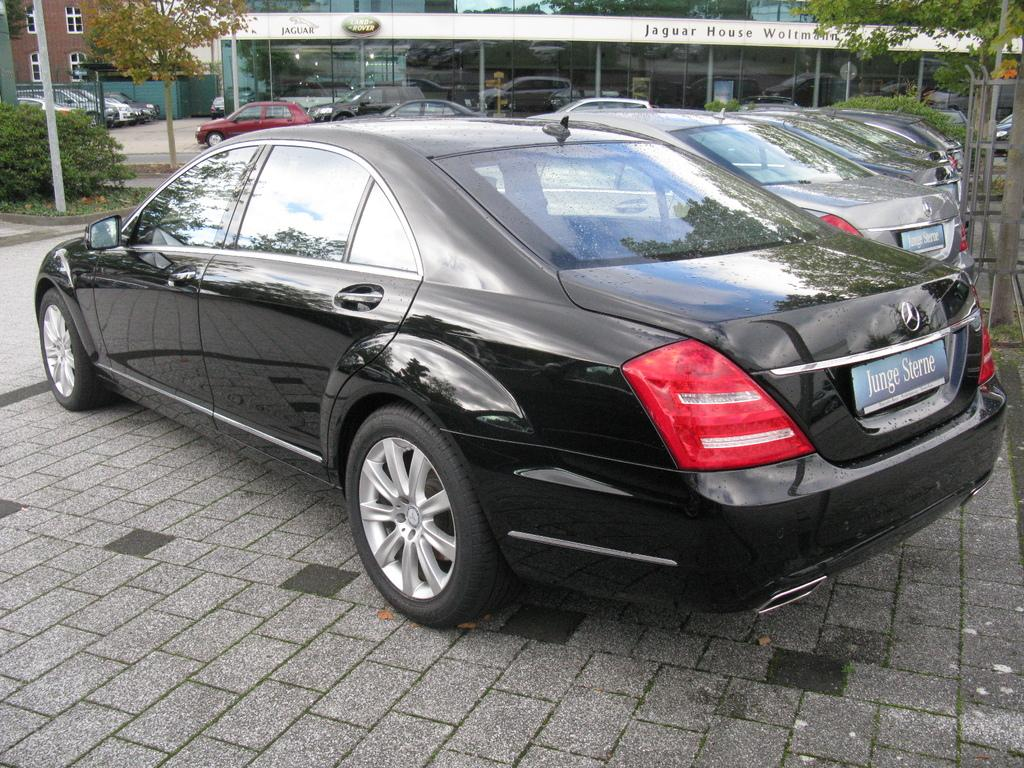What is happening on the road in the image? There are vehicles on the road in the image. What can be seen in the distance behind the vehicles? There are buildings, windows, trees, and poles visible in the background. How many pears are hanging from the poles in the image? There are no pears visible in the image; only buildings, windows, trees, and poles can be seen in the background. 